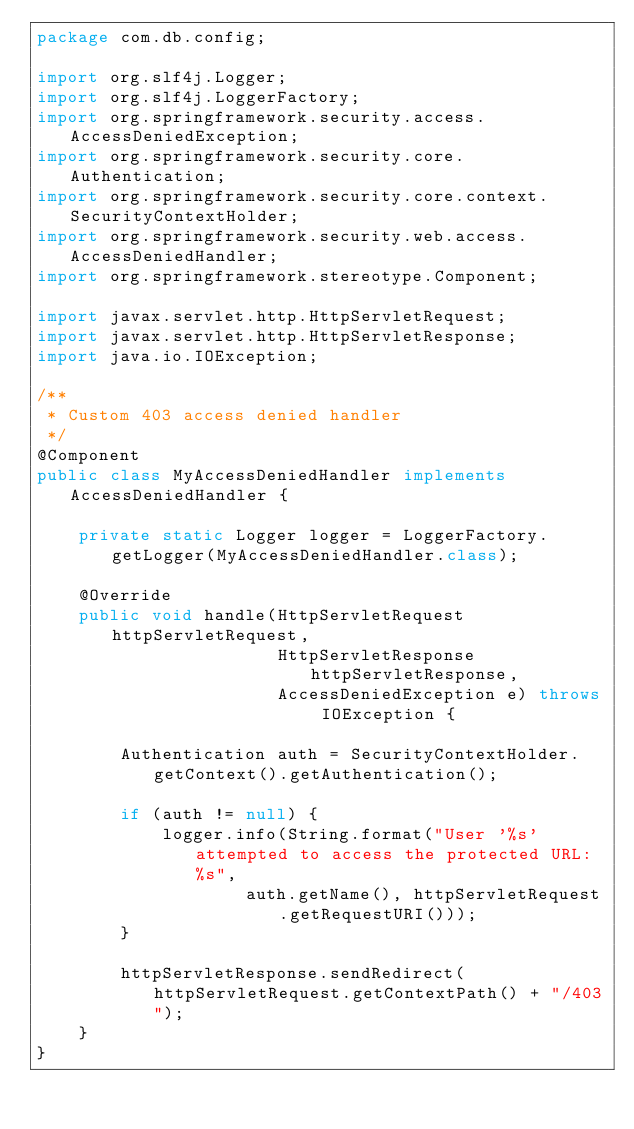Convert code to text. <code><loc_0><loc_0><loc_500><loc_500><_Java_>package com.db.config;

import org.slf4j.Logger;
import org.slf4j.LoggerFactory;
import org.springframework.security.access.AccessDeniedException;
import org.springframework.security.core.Authentication;
import org.springframework.security.core.context.SecurityContextHolder;
import org.springframework.security.web.access.AccessDeniedHandler;
import org.springframework.stereotype.Component;

import javax.servlet.http.HttpServletRequest;
import javax.servlet.http.HttpServletResponse;
import java.io.IOException;

/**
 * Custom 403 access denied handler
 */
@Component
public class MyAccessDeniedHandler implements AccessDeniedHandler {

    private static Logger logger = LoggerFactory.getLogger(MyAccessDeniedHandler.class);

    @Override
    public void handle(HttpServletRequest httpServletRequest,
                       HttpServletResponse httpServletResponse,
                       AccessDeniedException e) throws IOException {

        Authentication auth = SecurityContextHolder.getContext().getAuthentication();

        if (auth != null) {
            logger.info(String.format("User '%s' attempted to access the protected URL: %s",
                    auth.getName(), httpServletRequest.getRequestURI()));
        }

        httpServletResponse.sendRedirect(httpServletRequest.getContextPath() + "/403");
    }
}
</code> 